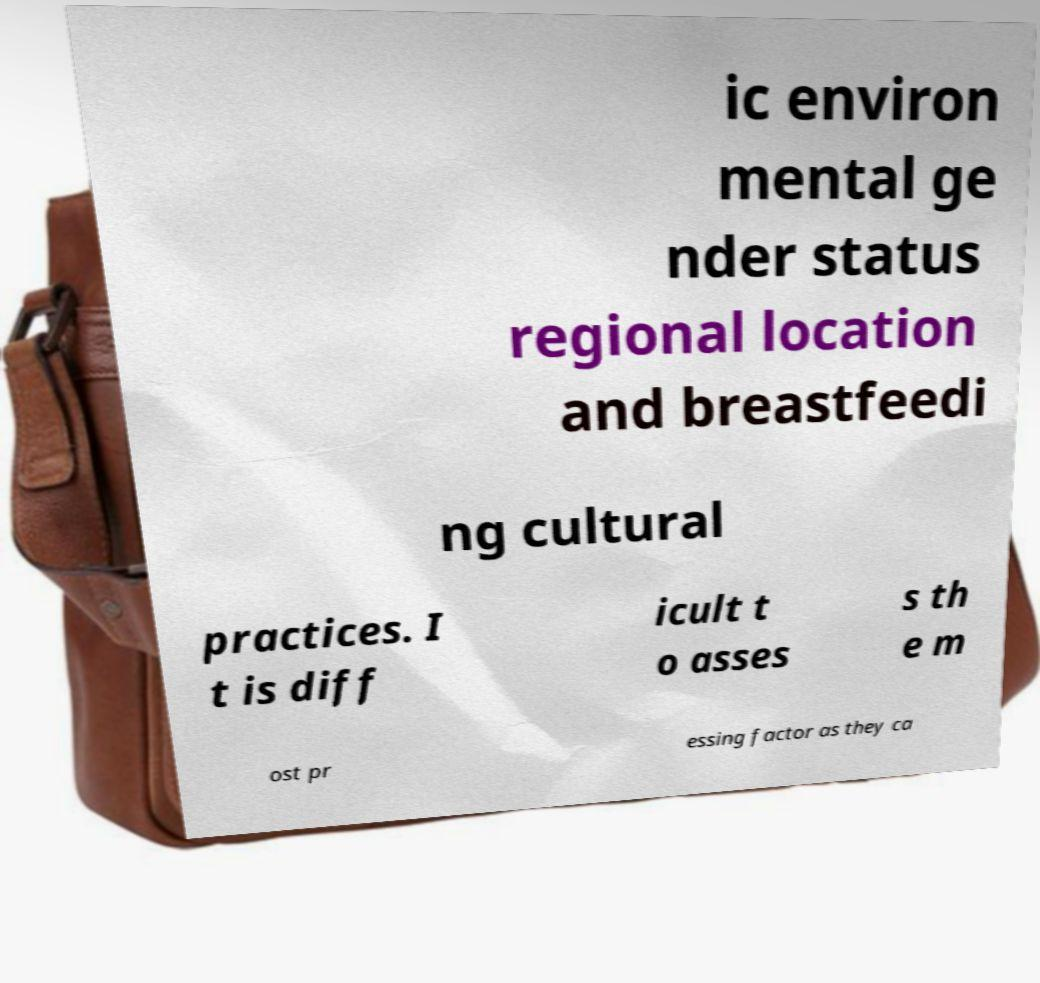Can you read and provide the text displayed in the image?This photo seems to have some interesting text. Can you extract and type it out for me? ic environ mental ge nder status regional location and breastfeedi ng cultural practices. I t is diff icult t o asses s th e m ost pr essing factor as they ca 